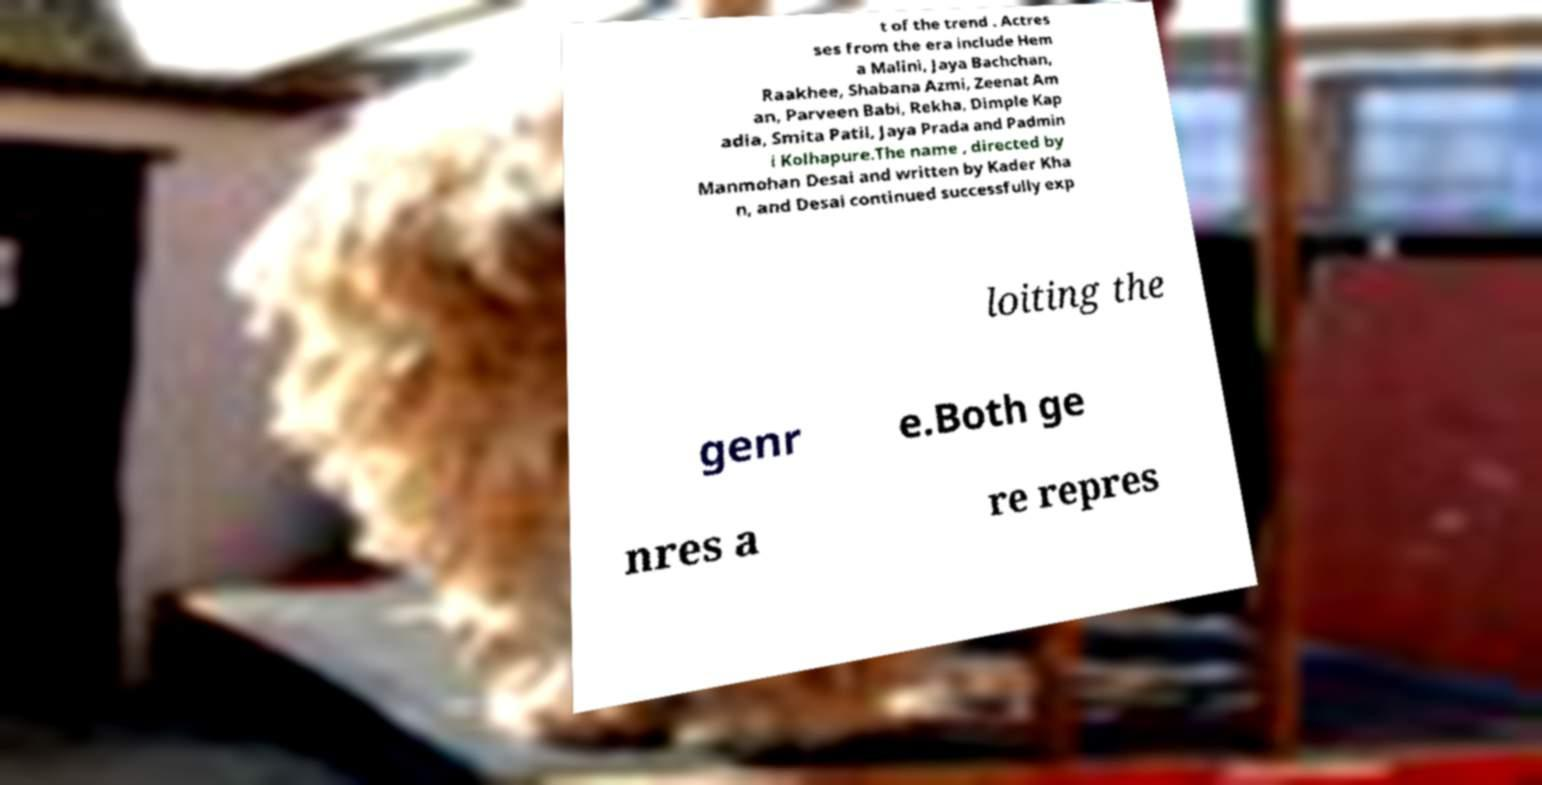What messages or text are displayed in this image? I need them in a readable, typed format. t of the trend . Actres ses from the era include Hem a Malini, Jaya Bachchan, Raakhee, Shabana Azmi, Zeenat Am an, Parveen Babi, Rekha, Dimple Kap adia, Smita Patil, Jaya Prada and Padmin i Kolhapure.The name , directed by Manmohan Desai and written by Kader Kha n, and Desai continued successfully exp loiting the genr e.Both ge nres a re repres 